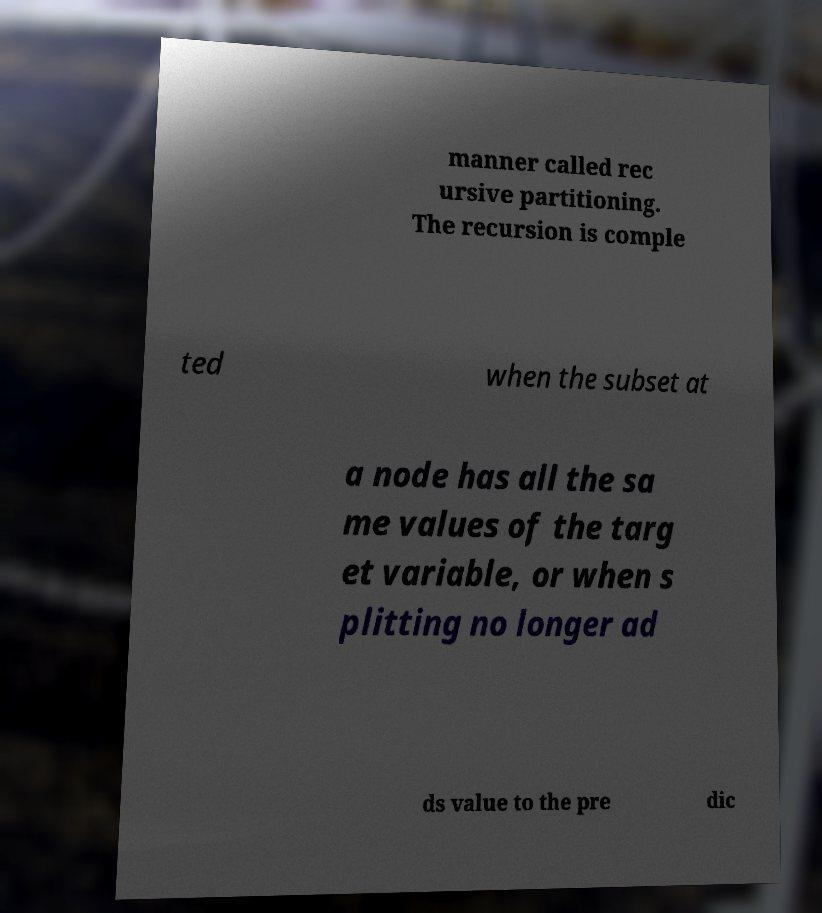I need the written content from this picture converted into text. Can you do that? manner called rec ursive partitioning. The recursion is comple ted when the subset at a node has all the sa me values of the targ et variable, or when s plitting no longer ad ds value to the pre dic 